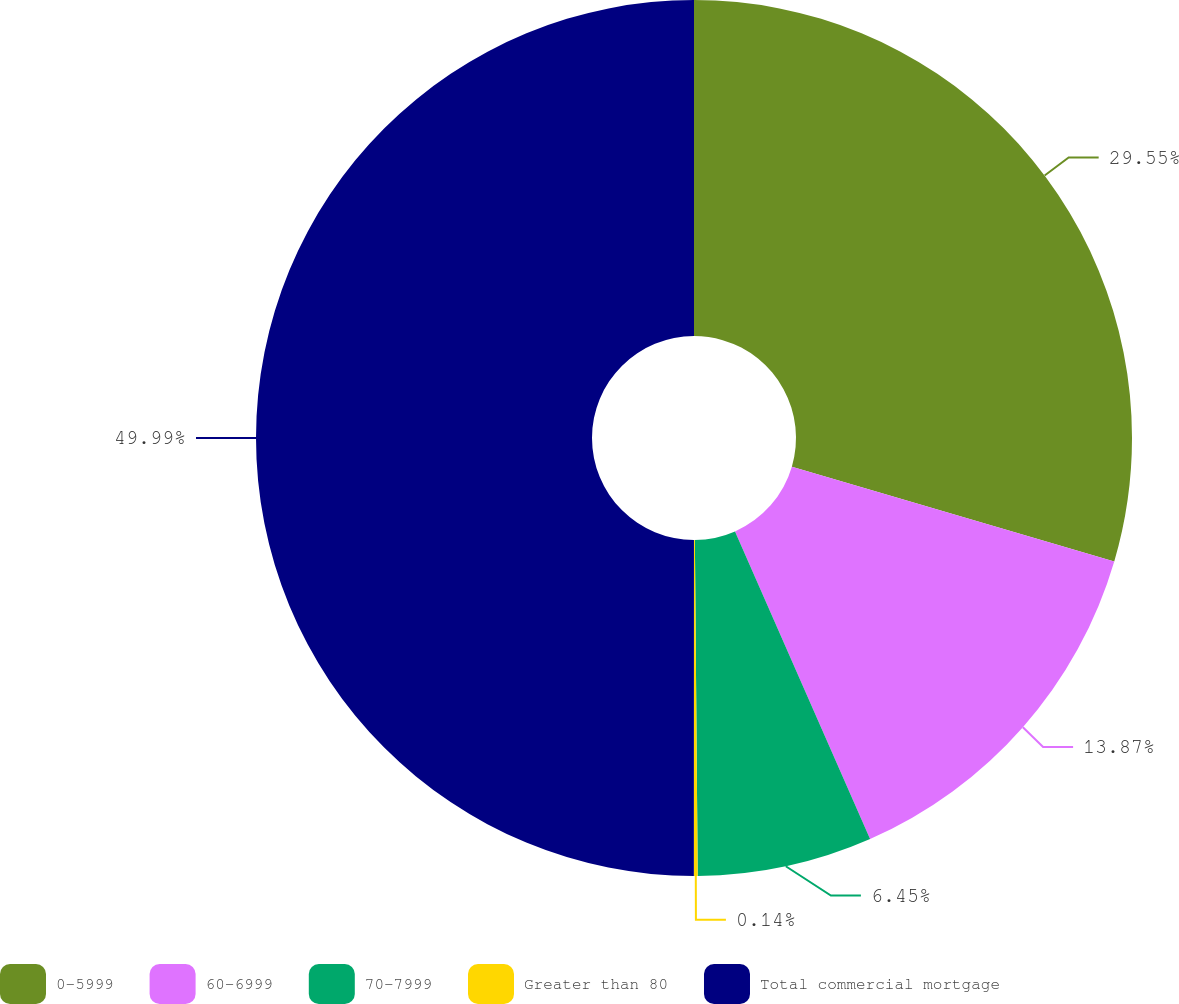<chart> <loc_0><loc_0><loc_500><loc_500><pie_chart><fcel>0-5999<fcel>60-6999<fcel>70-7999<fcel>Greater than 80<fcel>Total commercial mortgage<nl><fcel>29.55%<fcel>13.87%<fcel>6.45%<fcel>0.14%<fcel>50.0%<nl></chart> 